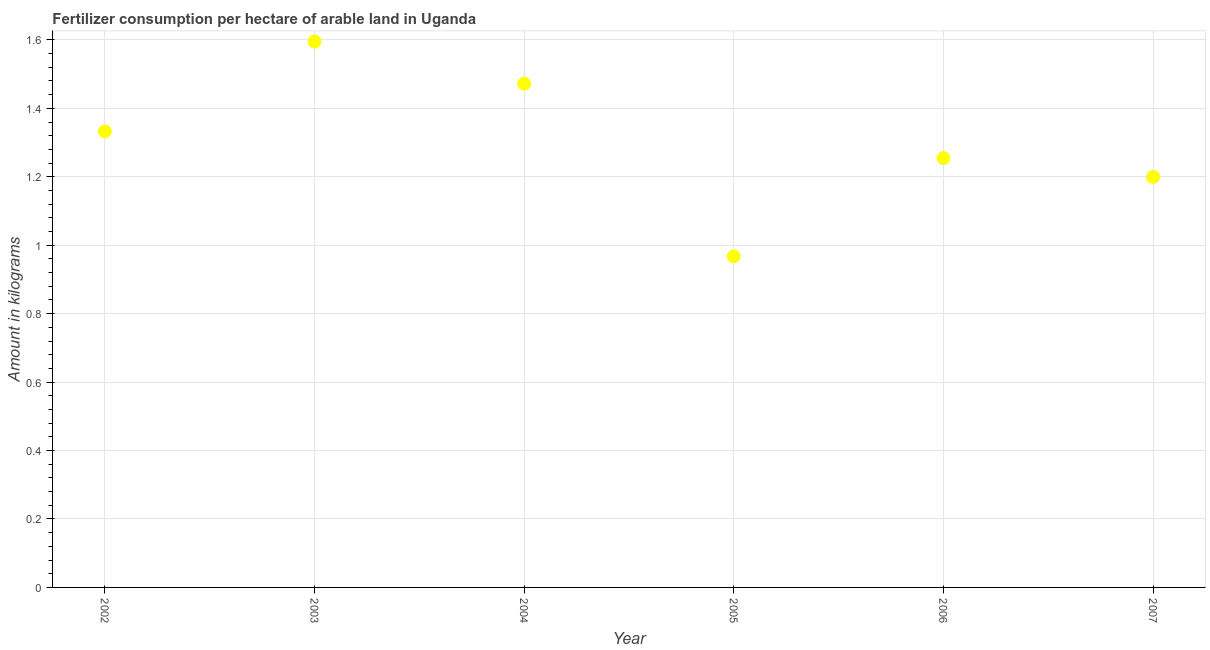What is the amount of fertilizer consumption in 2007?
Offer a very short reply. 1.2. Across all years, what is the maximum amount of fertilizer consumption?
Make the answer very short. 1.6. Across all years, what is the minimum amount of fertilizer consumption?
Keep it short and to the point. 0.97. What is the sum of the amount of fertilizer consumption?
Give a very brief answer. 7.82. What is the difference between the amount of fertilizer consumption in 2003 and 2004?
Offer a very short reply. 0.12. What is the average amount of fertilizer consumption per year?
Your response must be concise. 1.3. What is the median amount of fertilizer consumption?
Give a very brief answer. 1.29. In how many years, is the amount of fertilizer consumption greater than 1.08 kg?
Keep it short and to the point. 5. Do a majority of the years between 2007 and 2005 (inclusive) have amount of fertilizer consumption greater than 1.52 kg?
Provide a succinct answer. No. What is the ratio of the amount of fertilizer consumption in 2003 to that in 2007?
Your response must be concise. 1.33. Is the amount of fertilizer consumption in 2002 less than that in 2006?
Ensure brevity in your answer.  No. What is the difference between the highest and the second highest amount of fertilizer consumption?
Your response must be concise. 0.12. What is the difference between the highest and the lowest amount of fertilizer consumption?
Your answer should be very brief. 0.63. In how many years, is the amount of fertilizer consumption greater than the average amount of fertilizer consumption taken over all years?
Offer a terse response. 3. Does the amount of fertilizer consumption monotonically increase over the years?
Your answer should be compact. No. How many years are there in the graph?
Make the answer very short. 6. Are the values on the major ticks of Y-axis written in scientific E-notation?
Give a very brief answer. No. Does the graph contain grids?
Your answer should be compact. Yes. What is the title of the graph?
Make the answer very short. Fertilizer consumption per hectare of arable land in Uganda . What is the label or title of the Y-axis?
Offer a very short reply. Amount in kilograms. What is the Amount in kilograms in 2002?
Your answer should be compact. 1.33. What is the Amount in kilograms in 2003?
Make the answer very short. 1.6. What is the Amount in kilograms in 2004?
Make the answer very short. 1.47. What is the Amount in kilograms in 2005?
Make the answer very short. 0.97. What is the Amount in kilograms in 2006?
Keep it short and to the point. 1.25. What is the Amount in kilograms in 2007?
Offer a terse response. 1.2. What is the difference between the Amount in kilograms in 2002 and 2003?
Offer a terse response. -0.26. What is the difference between the Amount in kilograms in 2002 and 2004?
Make the answer very short. -0.14. What is the difference between the Amount in kilograms in 2002 and 2005?
Offer a terse response. 0.37. What is the difference between the Amount in kilograms in 2002 and 2006?
Provide a succinct answer. 0.08. What is the difference between the Amount in kilograms in 2002 and 2007?
Offer a very short reply. 0.13. What is the difference between the Amount in kilograms in 2003 and 2004?
Provide a succinct answer. 0.12. What is the difference between the Amount in kilograms in 2003 and 2005?
Your answer should be compact. 0.63. What is the difference between the Amount in kilograms in 2003 and 2006?
Ensure brevity in your answer.  0.34. What is the difference between the Amount in kilograms in 2003 and 2007?
Give a very brief answer. 0.4. What is the difference between the Amount in kilograms in 2004 and 2005?
Ensure brevity in your answer.  0.5. What is the difference between the Amount in kilograms in 2004 and 2006?
Make the answer very short. 0.22. What is the difference between the Amount in kilograms in 2004 and 2007?
Ensure brevity in your answer.  0.27. What is the difference between the Amount in kilograms in 2005 and 2006?
Ensure brevity in your answer.  -0.29. What is the difference between the Amount in kilograms in 2005 and 2007?
Give a very brief answer. -0.23. What is the difference between the Amount in kilograms in 2006 and 2007?
Offer a very short reply. 0.05. What is the ratio of the Amount in kilograms in 2002 to that in 2003?
Your response must be concise. 0.84. What is the ratio of the Amount in kilograms in 2002 to that in 2004?
Make the answer very short. 0.91. What is the ratio of the Amount in kilograms in 2002 to that in 2005?
Your answer should be compact. 1.38. What is the ratio of the Amount in kilograms in 2002 to that in 2006?
Offer a terse response. 1.06. What is the ratio of the Amount in kilograms in 2002 to that in 2007?
Your answer should be very brief. 1.11. What is the ratio of the Amount in kilograms in 2003 to that in 2004?
Make the answer very short. 1.08. What is the ratio of the Amount in kilograms in 2003 to that in 2005?
Offer a very short reply. 1.65. What is the ratio of the Amount in kilograms in 2003 to that in 2006?
Offer a very short reply. 1.27. What is the ratio of the Amount in kilograms in 2003 to that in 2007?
Make the answer very short. 1.33. What is the ratio of the Amount in kilograms in 2004 to that in 2005?
Offer a terse response. 1.52. What is the ratio of the Amount in kilograms in 2004 to that in 2006?
Offer a terse response. 1.17. What is the ratio of the Amount in kilograms in 2004 to that in 2007?
Ensure brevity in your answer.  1.23. What is the ratio of the Amount in kilograms in 2005 to that in 2006?
Provide a short and direct response. 0.77. What is the ratio of the Amount in kilograms in 2005 to that in 2007?
Make the answer very short. 0.81. What is the ratio of the Amount in kilograms in 2006 to that in 2007?
Ensure brevity in your answer.  1.05. 